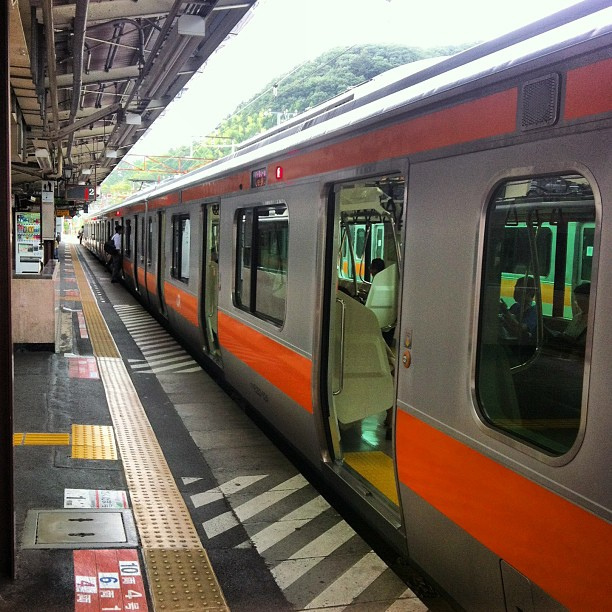Identify the text displayed in this image. 10 6 